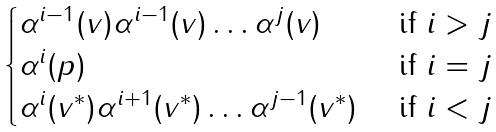<formula> <loc_0><loc_0><loc_500><loc_500>\begin{cases} \alpha ^ { i - 1 } ( v ) \alpha ^ { i - 1 } ( v ) \dots \alpha ^ { j } ( v ) & \text { if } i > j \\ \alpha ^ { i } ( p ) & \text { if } i = j \\ \alpha ^ { i } ( v ^ { * } ) \alpha ^ { i + 1 } ( v ^ { * } ) \dots \alpha ^ { j - 1 } ( v ^ { * } ) & \text { if } i < j \end{cases}</formula> 